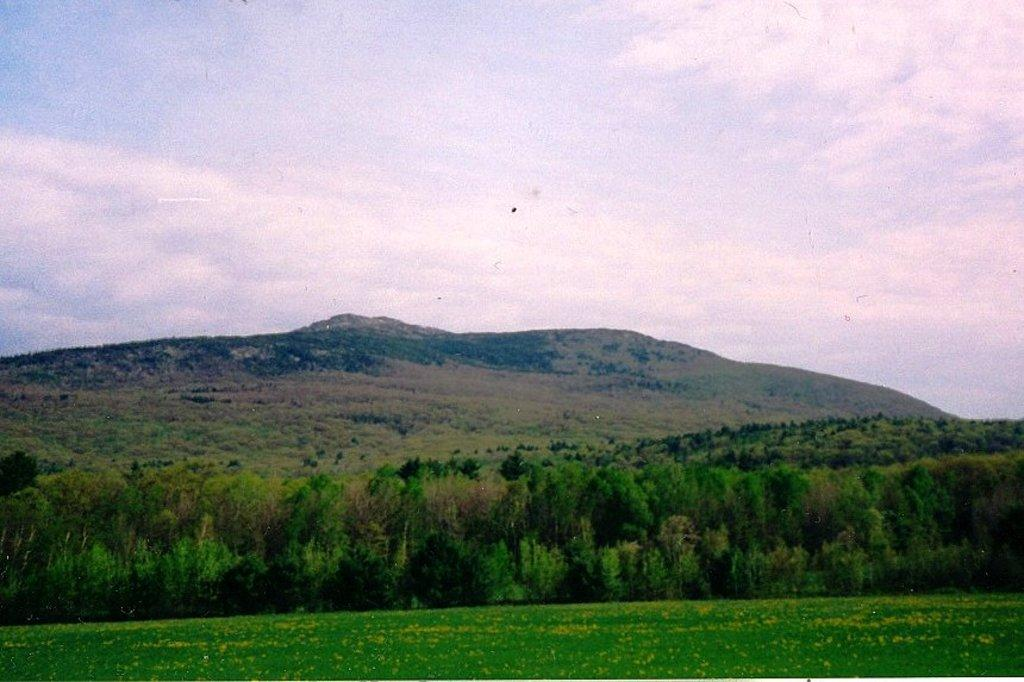What type of vegetation can be seen in the image? There are trees in the image. What is the color of the trees? The trees are green. What can be seen in the background of the image? There are mountains visible in the background of the image. What is visible in the sky in the image? The sky is visible in the image, and it has both white and blue colors. What type of order is being followed by the dolls in the image? There are no dolls present in the image, so there is no order being followed by dolls. 